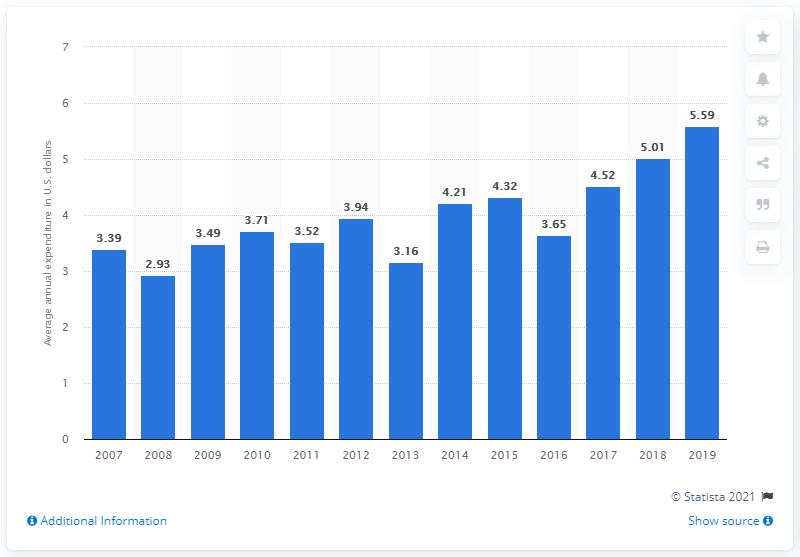Outline some significant characteristics in this image. In 2019, the average expenditure on slipcovers and decorative pillows per consumer unit in the United States was approximately $5.59. 